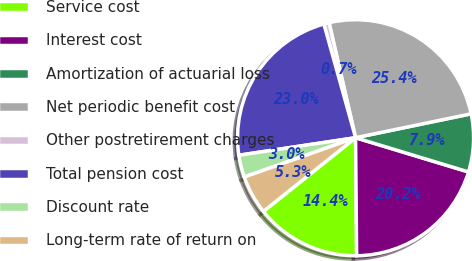Convert chart. <chart><loc_0><loc_0><loc_500><loc_500><pie_chart><fcel>Service cost<fcel>Interest cost<fcel>Amortization of actuarial loss<fcel>Net periodic benefit cost<fcel>Other postretirement charges<fcel>Total pension cost<fcel>Discount rate<fcel>Long-term rate of return on<nl><fcel>14.41%<fcel>20.17%<fcel>7.93%<fcel>25.36%<fcel>0.72%<fcel>23.05%<fcel>3.03%<fcel>5.33%<nl></chart> 